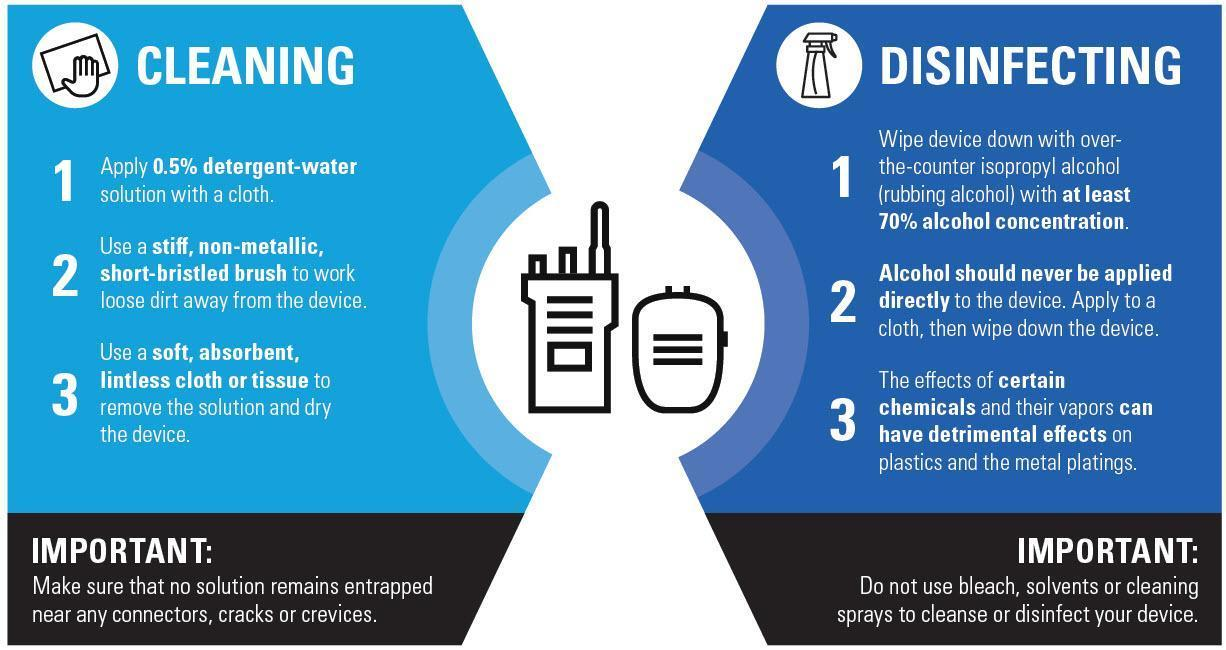What type of brush can be used for cleaning?
Answer the question with a short phrase. stiff, non-metallic, short-bristled brush what is the common name for isopropyl alcohol? rubbing alcohol How should the cloth used to remove the solution be? soft, absorbent, lintless What solution should be used for cleaning? 0.5% detergent-water solution What should be used to remove the solution and dry the device? cloth or tissue 